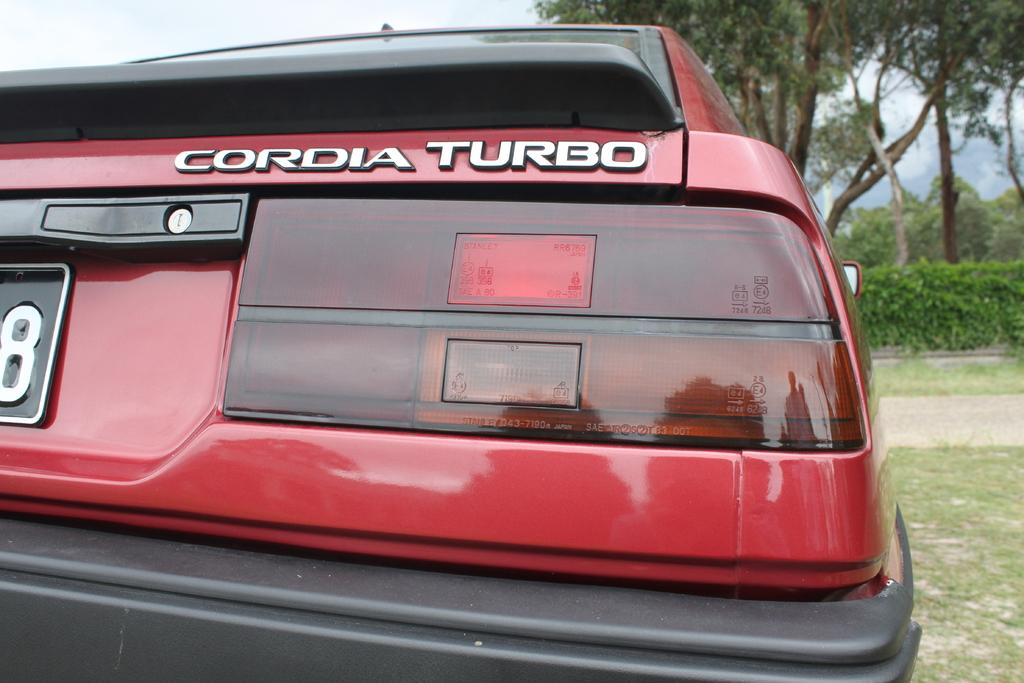<image>
Render a clear and concise summary of the photo. A red car that says Cordia Turbo is parked in the grass. 